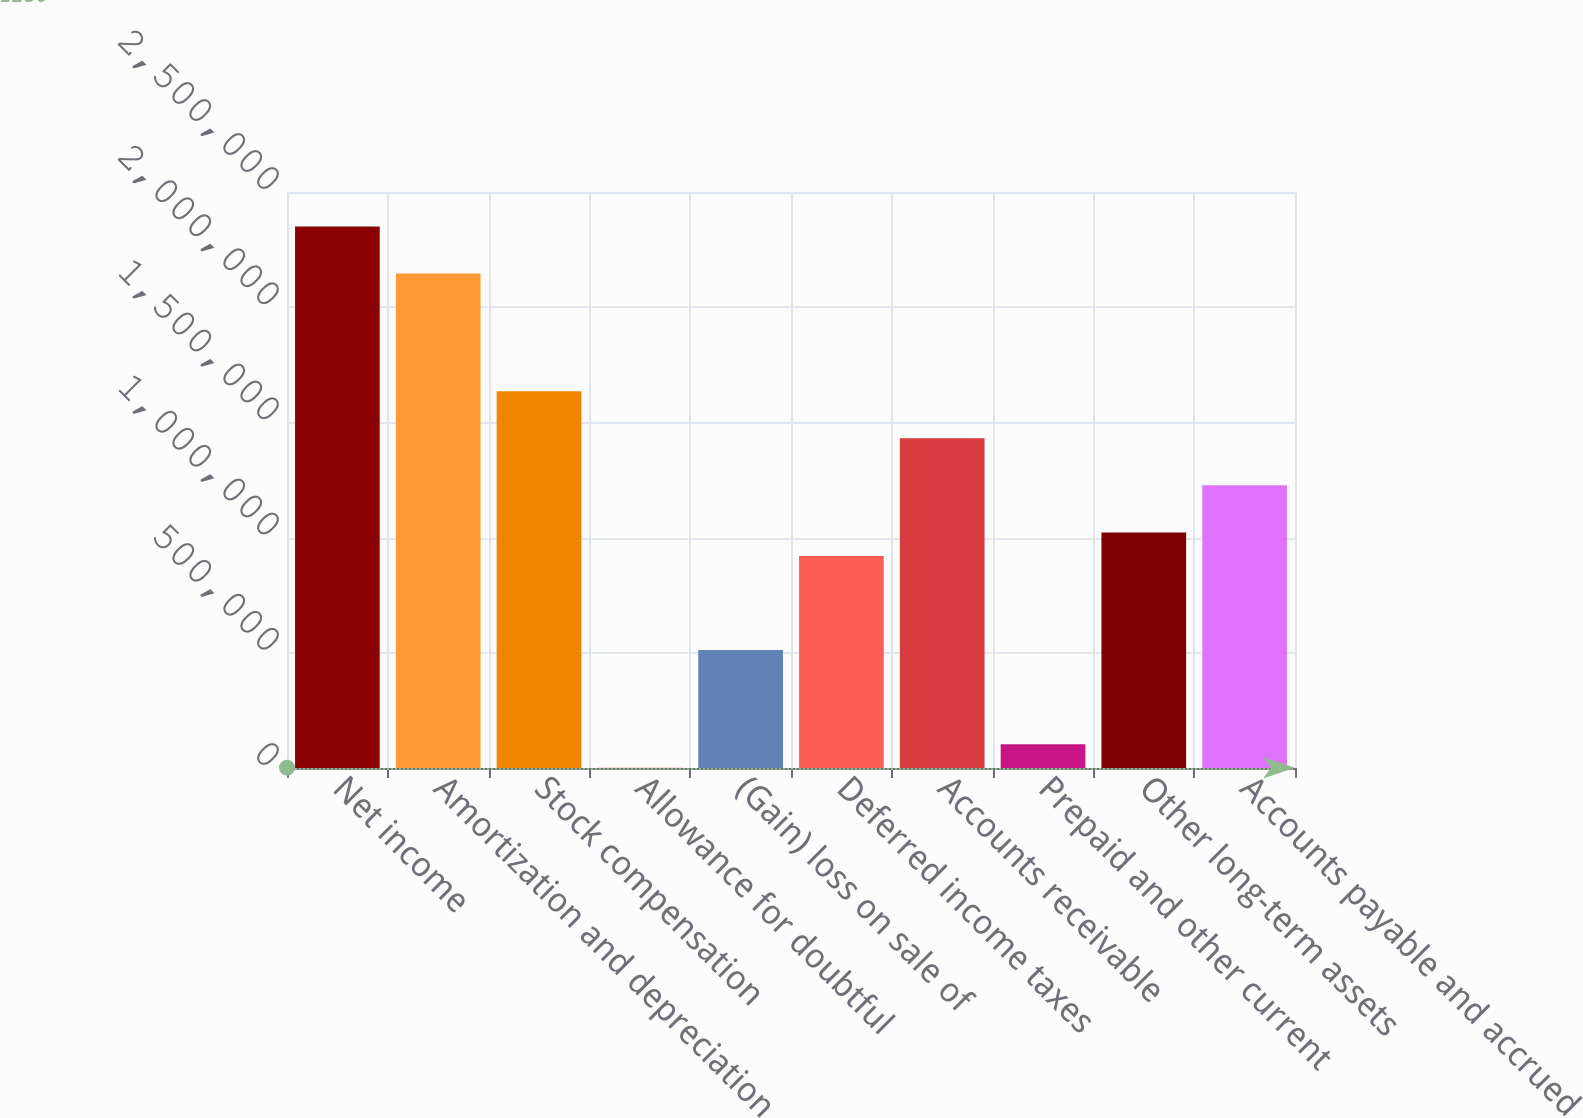Convert chart to OTSL. <chart><loc_0><loc_0><loc_500><loc_500><bar_chart><fcel>Net income<fcel>Amortization and depreciation<fcel>Stock compensation<fcel>Allowance for doubtful<fcel>(Gain) loss on sale of<fcel>Deferred income taxes<fcel>Accounts receivable<fcel>Prepaid and other current<fcel>Other long-term assets<fcel>Accounts payable and accrued<nl><fcel>2.34999e+06<fcel>2.14575e+06<fcel>1.63516e+06<fcel>1250<fcel>511846<fcel>920322<fcel>1.43092e+06<fcel>103369<fcel>1.02244e+06<fcel>1.22668e+06<nl></chart> 